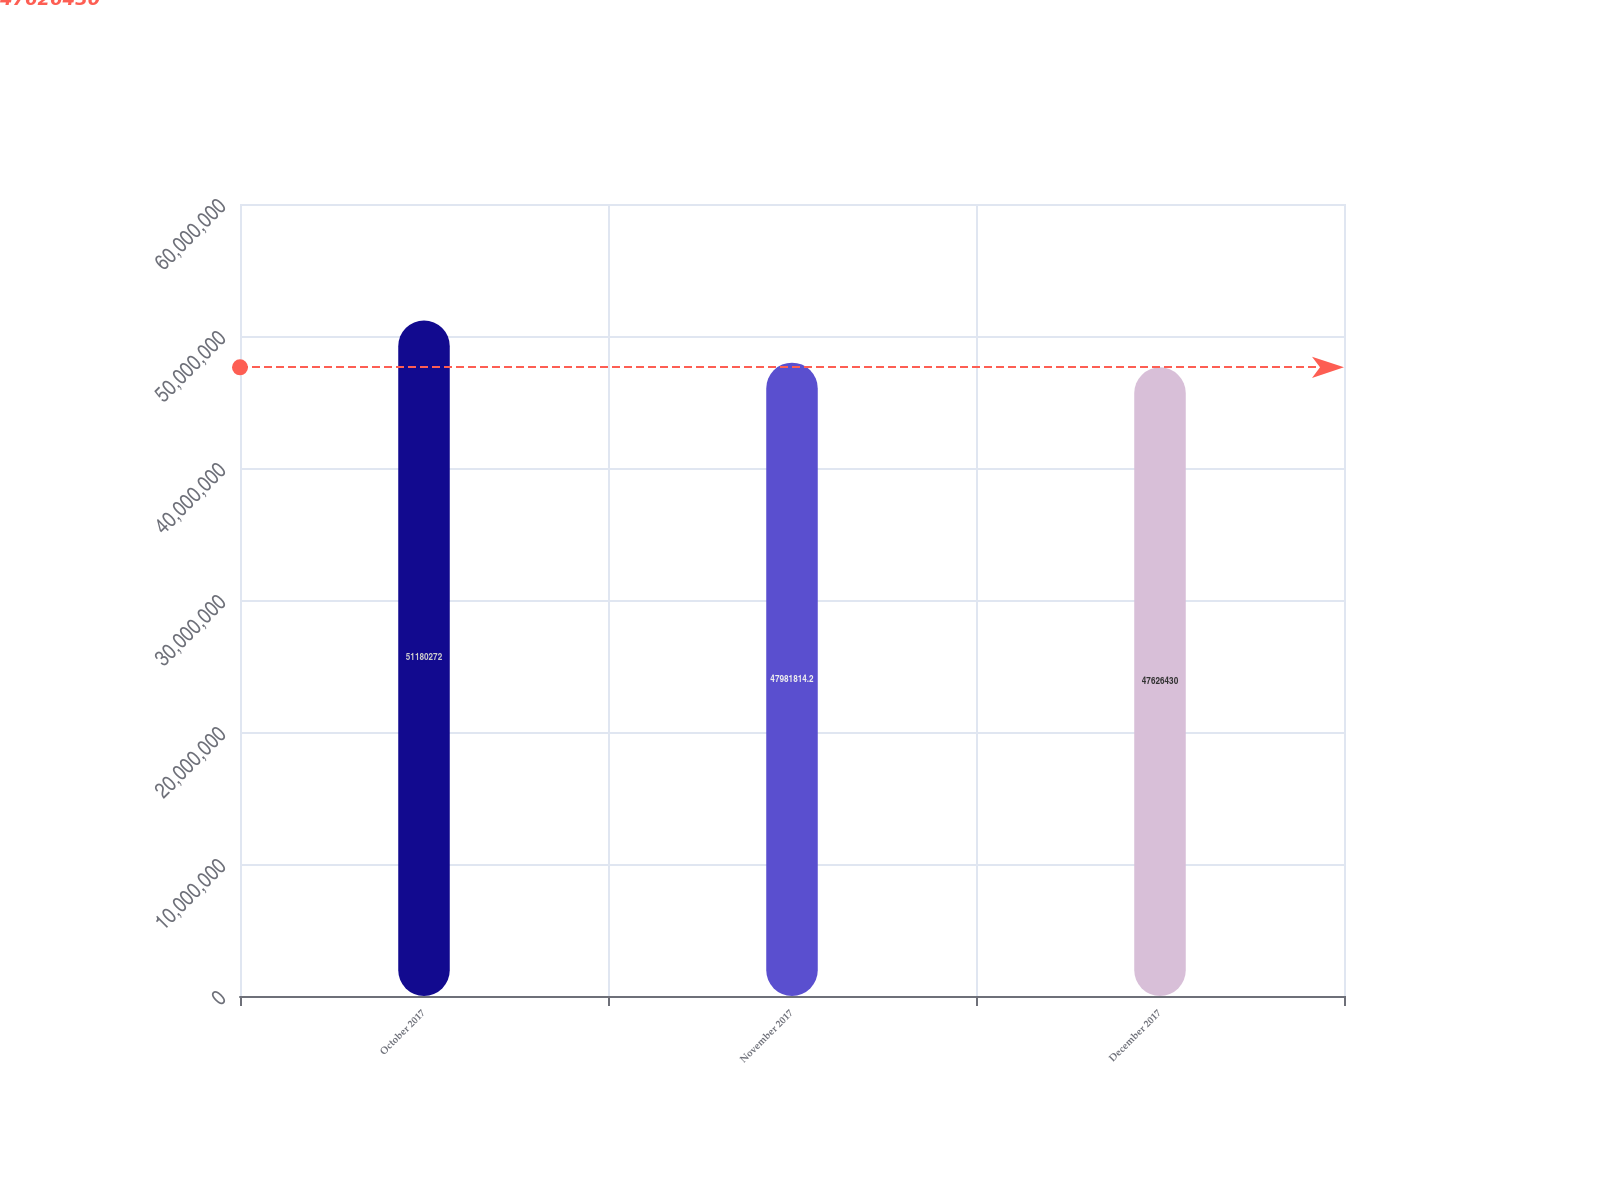Convert chart. <chart><loc_0><loc_0><loc_500><loc_500><bar_chart><fcel>October 2017<fcel>November 2017<fcel>December 2017<nl><fcel>5.11803e+07<fcel>4.79818e+07<fcel>4.76264e+07<nl></chart> 